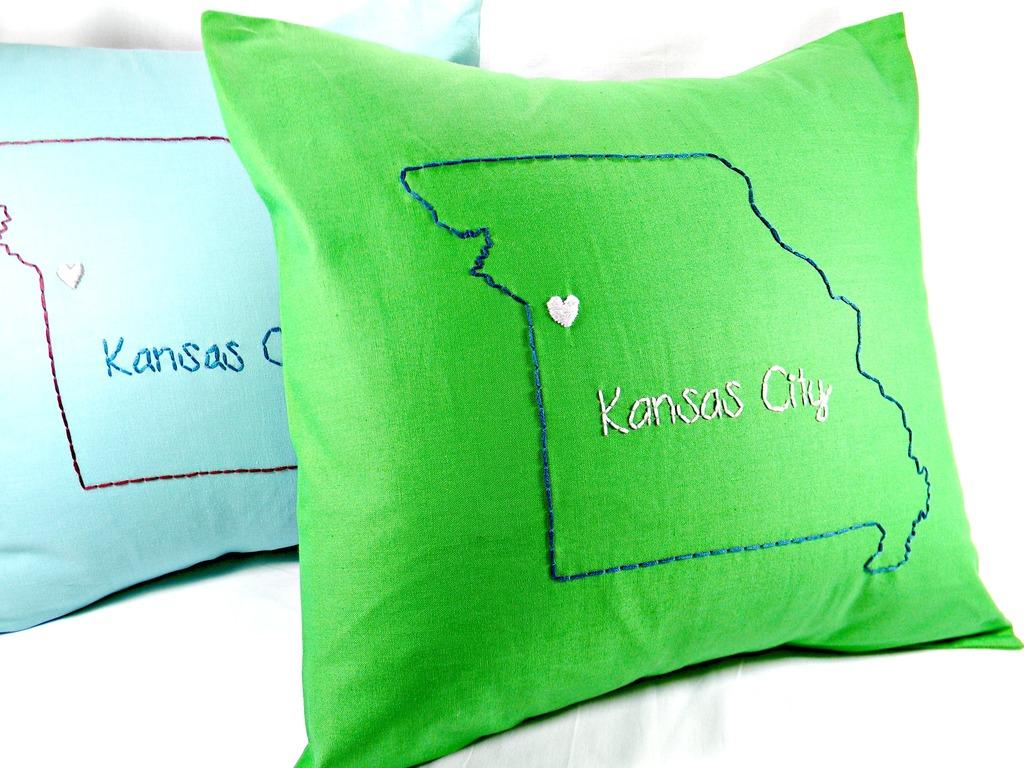How many cushions are in the image? There are two cushions in the image. What colors are the cushions? One cushion is green in color, and the other cushion is blue in color. Is there any text on the cushions? Yes, there is text on the cushions. What is the color of the background in the image? The background of the image is white. How many pages can be seen in the image? There are no pages present in the image; it features two cushions with text on them. What type of bike is visible in the image? There is no bike present in the image. 